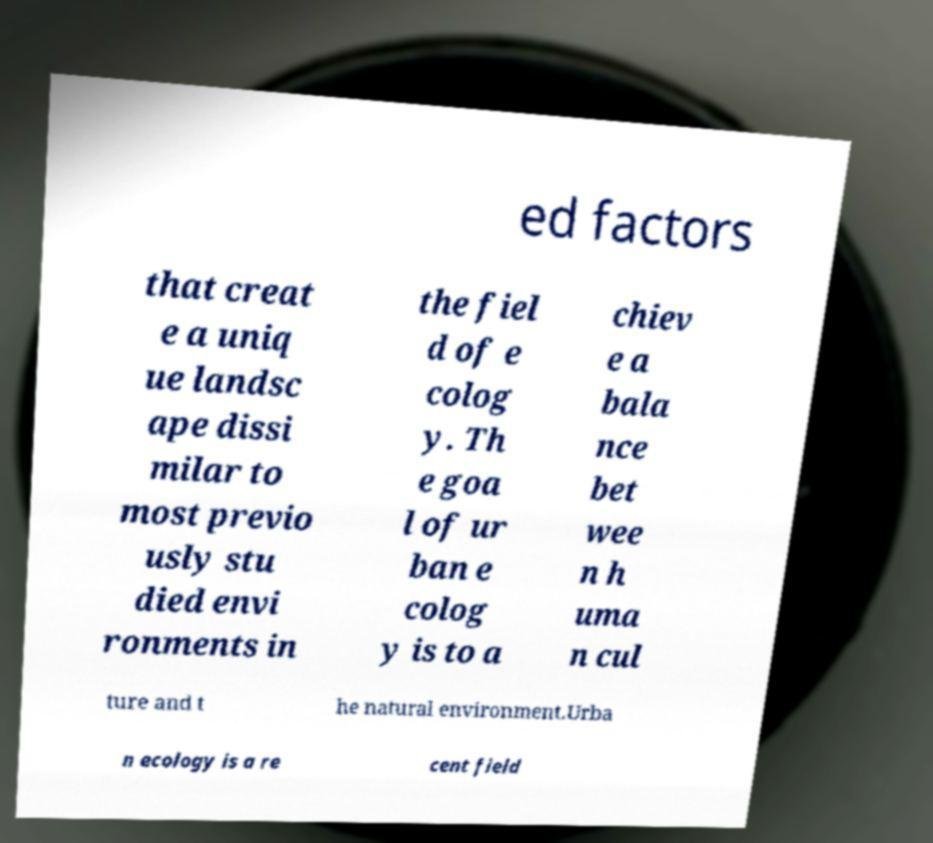Please identify and transcribe the text found in this image. ed factors that creat e a uniq ue landsc ape dissi milar to most previo usly stu died envi ronments in the fiel d of e colog y. Th e goa l of ur ban e colog y is to a chiev e a bala nce bet wee n h uma n cul ture and t he natural environment.Urba n ecology is a re cent field 